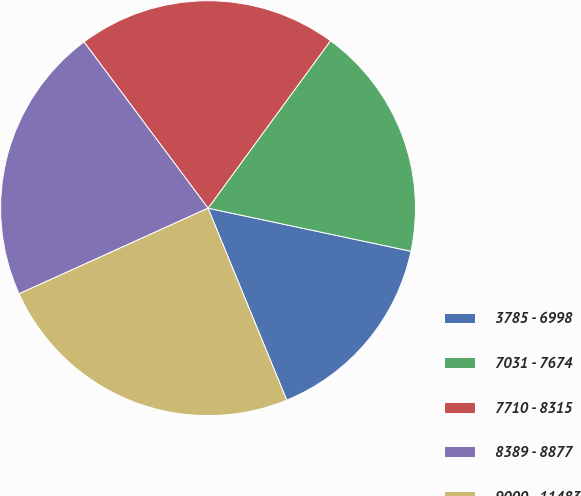Convert chart to OTSL. <chart><loc_0><loc_0><loc_500><loc_500><pie_chart><fcel>3785 - 6998<fcel>7031 - 7674<fcel>7710 - 8315<fcel>8389 - 8877<fcel>9000 - 11483<nl><fcel>15.48%<fcel>18.28%<fcel>20.25%<fcel>21.57%<fcel>24.42%<nl></chart> 